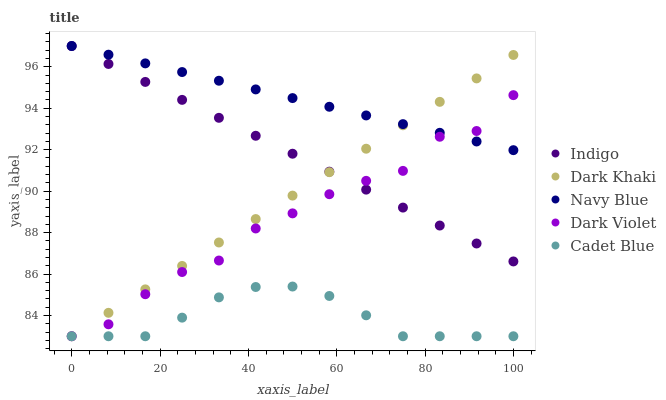Does Cadet Blue have the minimum area under the curve?
Answer yes or no. Yes. Does Navy Blue have the maximum area under the curve?
Answer yes or no. Yes. Does Navy Blue have the minimum area under the curve?
Answer yes or no. No. Does Cadet Blue have the maximum area under the curve?
Answer yes or no. No. Is Dark Khaki the smoothest?
Answer yes or no. Yes. Is Dark Violet the roughest?
Answer yes or no. Yes. Is Navy Blue the smoothest?
Answer yes or no. No. Is Navy Blue the roughest?
Answer yes or no. No. Does Dark Khaki have the lowest value?
Answer yes or no. Yes. Does Navy Blue have the lowest value?
Answer yes or no. No. Does Indigo have the highest value?
Answer yes or no. Yes. Does Cadet Blue have the highest value?
Answer yes or no. No. Is Cadet Blue less than Navy Blue?
Answer yes or no. Yes. Is Navy Blue greater than Cadet Blue?
Answer yes or no. Yes. Does Cadet Blue intersect Dark Violet?
Answer yes or no. Yes. Is Cadet Blue less than Dark Violet?
Answer yes or no. No. Is Cadet Blue greater than Dark Violet?
Answer yes or no. No. Does Cadet Blue intersect Navy Blue?
Answer yes or no. No. 